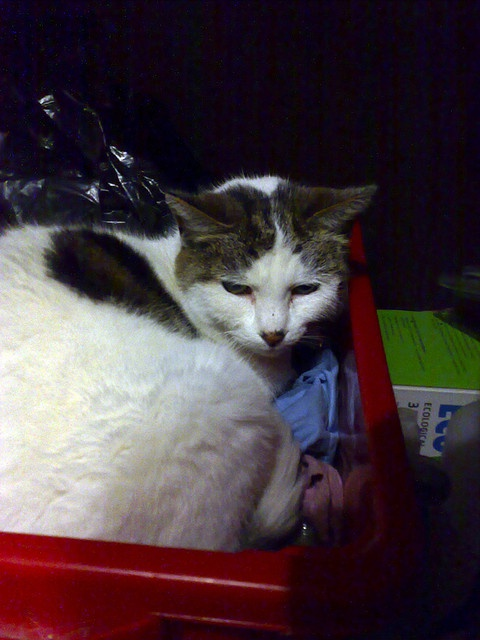Describe the objects in this image and their specific colors. I can see a cat in black, lightgray, darkgray, and gray tones in this image. 